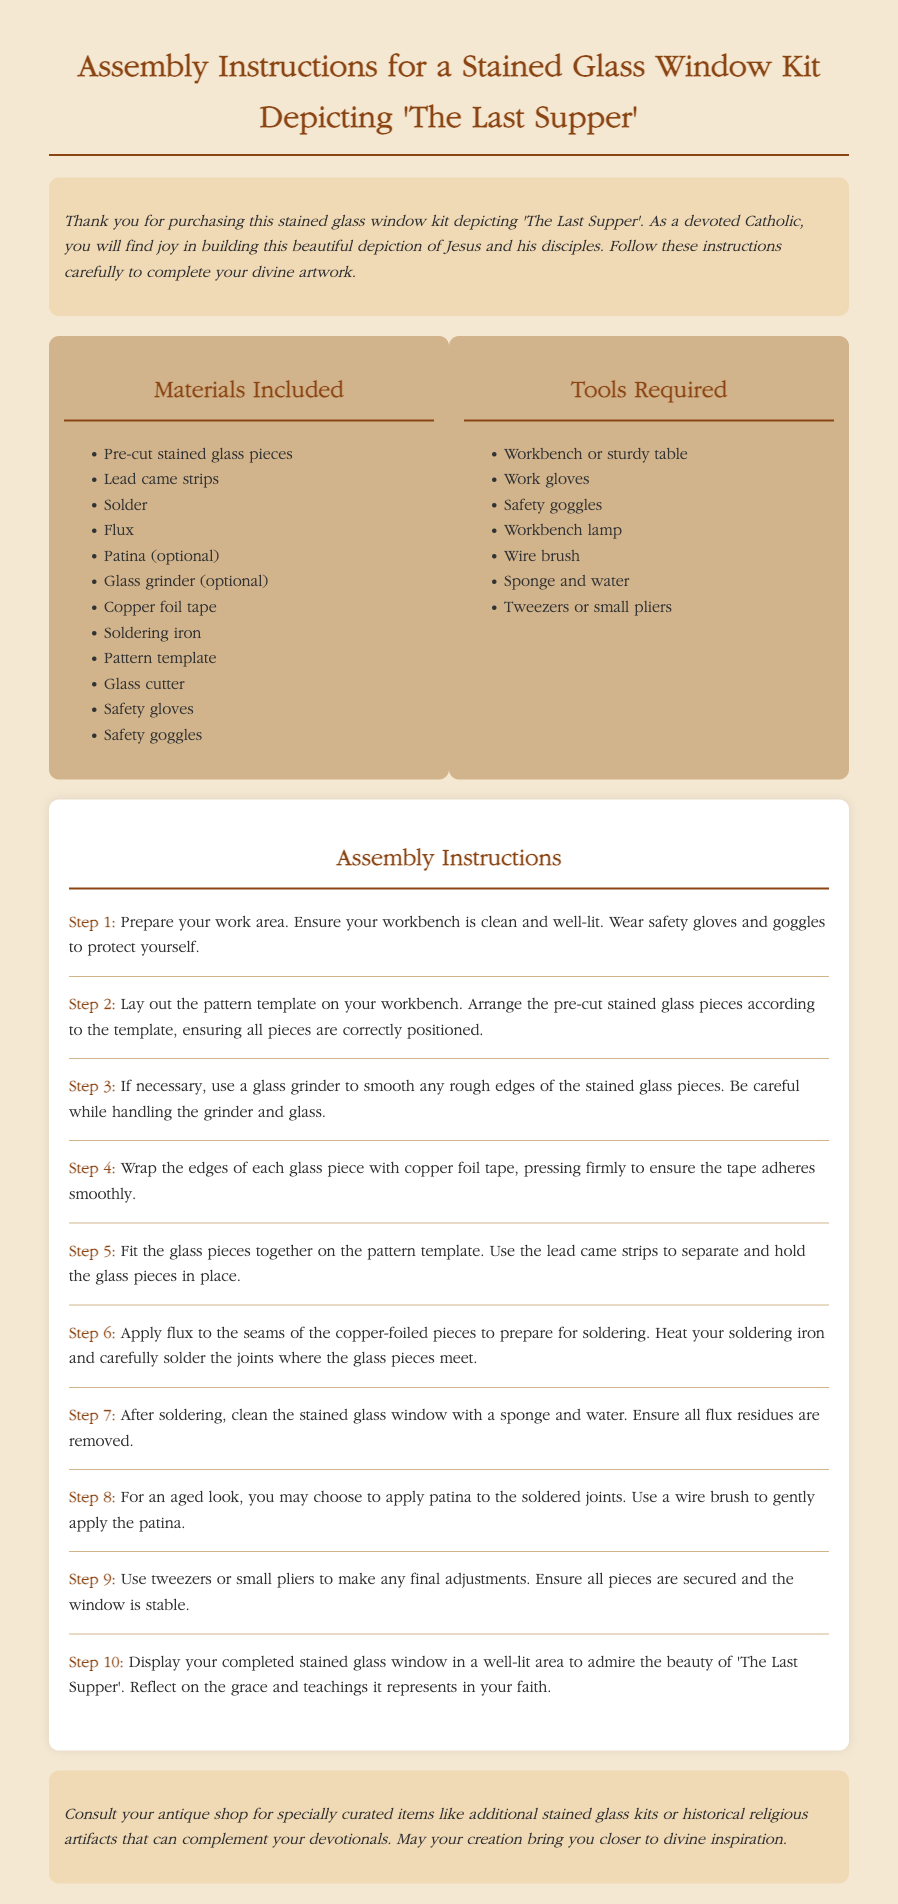What is the title of the stained glass window kit? The title is explicitly stated at the beginning of the document.
Answer: Assembly Instructions for a Stained Glass Window Kit Depicting 'The Last Supper' How many steps are included in the assembly instructions? The document lists steps, and the last one is number 10, indicating there are a total of 10 steps.
Answer: 10 What safety equipment is mentioned in the materials included? The document includes a list of materials where safety equipment is mentioned.
Answer: Safety gloves, Safety goggles What is the optional material listed for finishing touches? The document lists various materials, and one is marked as optional for aesthetic purposes.
Answer: Patina What must be applied to the seams before soldering? The instructions detail a preparation step before a specific action, requiring application.
Answer: Flux What should be done after soldering? The document specifies a cleaning procedure right after soldering in a step.
Answer: Clean the stained glass window with a sponge and water What tool is recommended for smoothing rough edges? The instructions suggest a specific tool for preparation of the glass pieces.
Answer: Glass grinder What is the final display advice given in the assembly instructions? The last step provides guidance on where to showcase the finished product.
Answer: Display your completed stained glass window in a well-lit area What do the instructions suggest you consult your antique shop for? The document offers a suggestion related to visiting an antique shop for certain items.
Answer: Specially curated items like additional stained glass kits or historical religious artifacts 